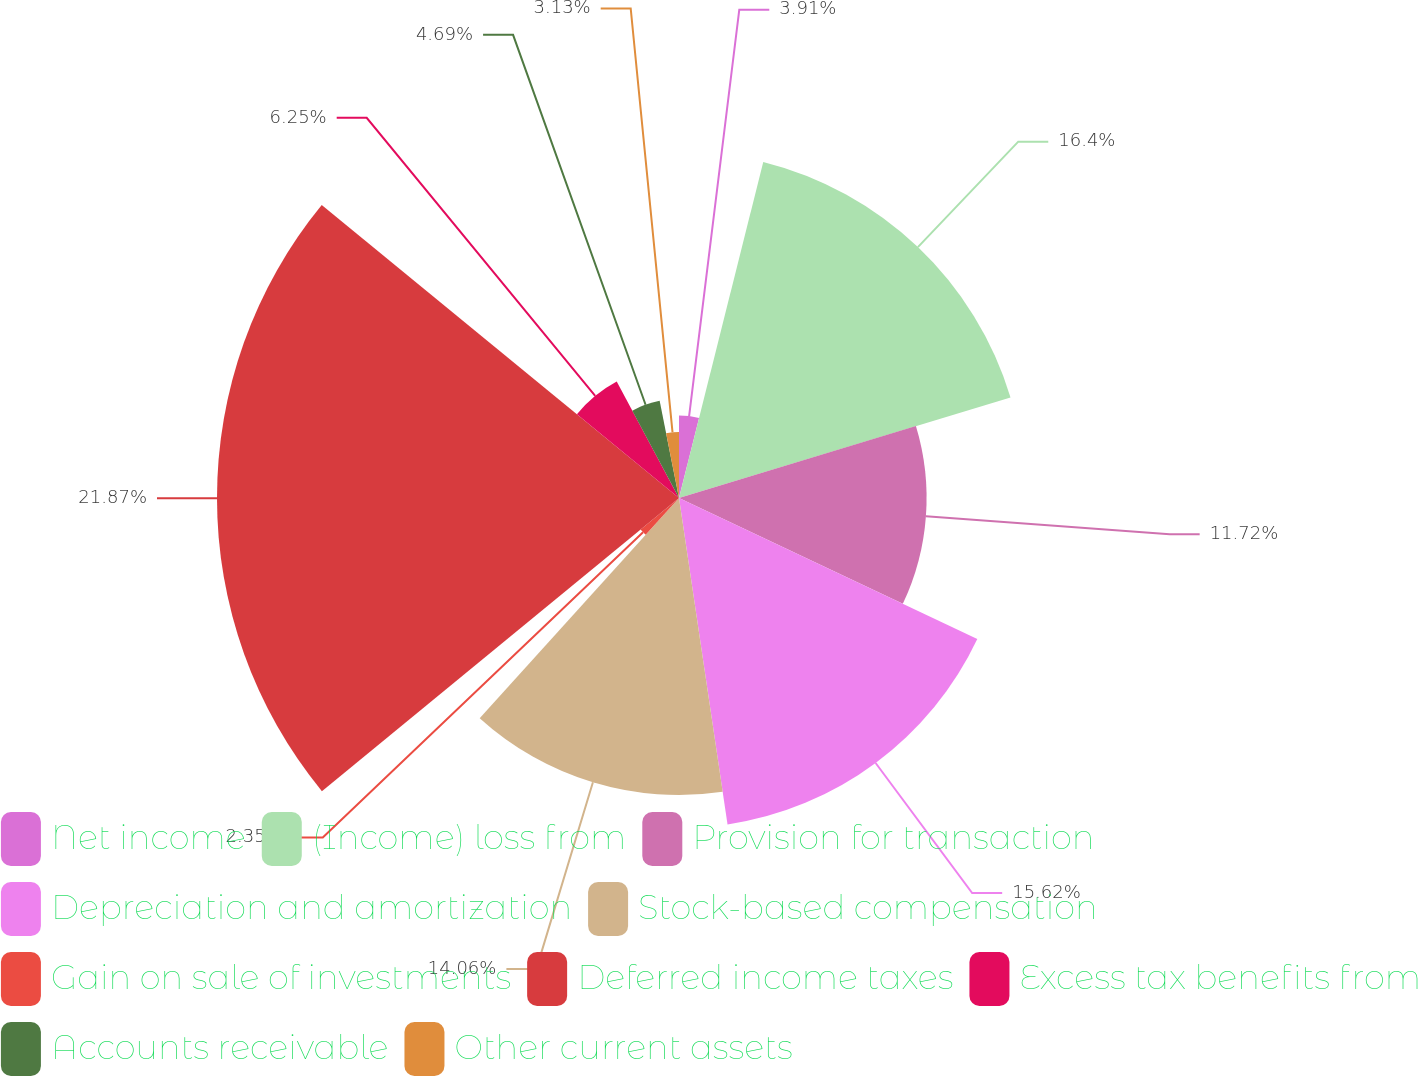<chart> <loc_0><loc_0><loc_500><loc_500><pie_chart><fcel>Net income<fcel>(Income) loss from<fcel>Provision for transaction<fcel>Depreciation and amortization<fcel>Stock-based compensation<fcel>Gain on sale of investments<fcel>Deferred income taxes<fcel>Excess tax benefits from<fcel>Accounts receivable<fcel>Other current assets<nl><fcel>3.91%<fcel>16.4%<fcel>11.72%<fcel>15.62%<fcel>14.06%<fcel>2.35%<fcel>21.87%<fcel>6.25%<fcel>4.69%<fcel>3.13%<nl></chart> 